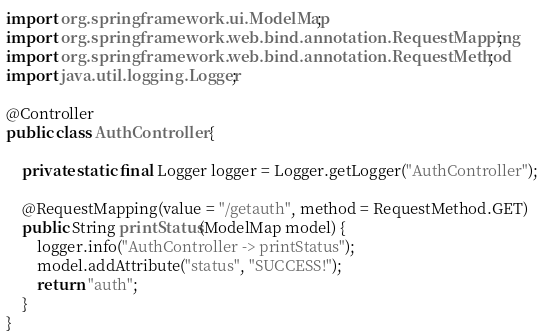<code> <loc_0><loc_0><loc_500><loc_500><_Java_>import org.springframework.ui.ModelMap;
import org.springframework.web.bind.annotation.RequestMapping;
import org.springframework.web.bind.annotation.RequestMethod;
import java.util.logging.Logger;

@Controller
public class AuthController {

	private static final Logger logger = Logger.getLogger("AuthController");

	@RequestMapping(value = "/getauth", method = RequestMethod.GET)
	public String printStatus(ModelMap model) {
		logger.info("AuthController -> printStatus");
		model.addAttribute("status", "SUCCESS!");
		return "auth";
	}
}</code> 